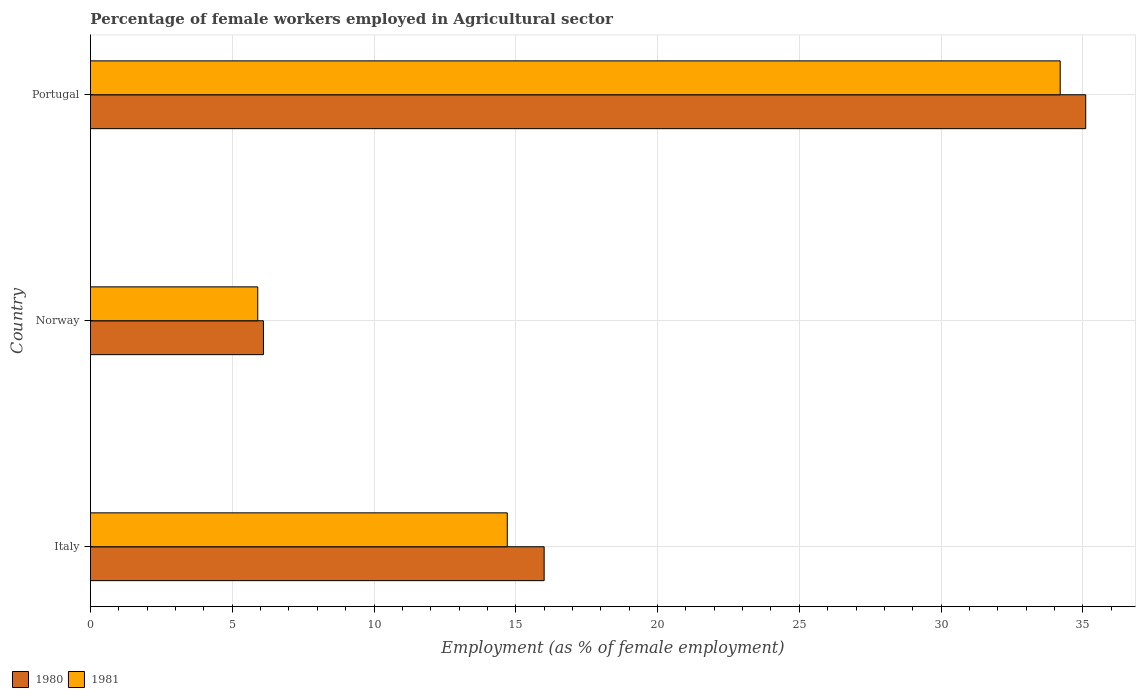How many different coloured bars are there?
Offer a very short reply. 2. How many groups of bars are there?
Offer a terse response. 3. Are the number of bars per tick equal to the number of legend labels?
Ensure brevity in your answer.  Yes. What is the label of the 3rd group of bars from the top?
Give a very brief answer. Italy. In how many cases, is the number of bars for a given country not equal to the number of legend labels?
Make the answer very short. 0. What is the percentage of females employed in Agricultural sector in 1981 in Norway?
Your answer should be very brief. 5.9. Across all countries, what is the maximum percentage of females employed in Agricultural sector in 1980?
Keep it short and to the point. 35.1. Across all countries, what is the minimum percentage of females employed in Agricultural sector in 1980?
Keep it short and to the point. 6.1. In which country was the percentage of females employed in Agricultural sector in 1981 maximum?
Offer a terse response. Portugal. In which country was the percentage of females employed in Agricultural sector in 1981 minimum?
Provide a succinct answer. Norway. What is the total percentage of females employed in Agricultural sector in 1981 in the graph?
Offer a terse response. 54.8. What is the difference between the percentage of females employed in Agricultural sector in 1981 in Italy and that in Norway?
Provide a short and direct response. 8.8. What is the difference between the percentage of females employed in Agricultural sector in 1980 in Italy and the percentage of females employed in Agricultural sector in 1981 in Norway?
Your answer should be compact. 10.1. What is the average percentage of females employed in Agricultural sector in 1981 per country?
Offer a terse response. 18.27. What is the difference between the percentage of females employed in Agricultural sector in 1980 and percentage of females employed in Agricultural sector in 1981 in Italy?
Offer a terse response. 1.3. What is the ratio of the percentage of females employed in Agricultural sector in 1981 in Italy to that in Portugal?
Your response must be concise. 0.43. Is the percentage of females employed in Agricultural sector in 1980 in Italy less than that in Portugal?
Provide a short and direct response. Yes. Is the difference between the percentage of females employed in Agricultural sector in 1980 in Italy and Portugal greater than the difference between the percentage of females employed in Agricultural sector in 1981 in Italy and Portugal?
Provide a succinct answer. Yes. What is the difference between the highest and the second highest percentage of females employed in Agricultural sector in 1981?
Offer a very short reply. 19.5. What is the difference between the highest and the lowest percentage of females employed in Agricultural sector in 1980?
Provide a succinct answer. 29. Is the sum of the percentage of females employed in Agricultural sector in 1981 in Italy and Norway greater than the maximum percentage of females employed in Agricultural sector in 1980 across all countries?
Provide a short and direct response. No. What does the 2nd bar from the top in Norway represents?
Your answer should be compact. 1980. How many bars are there?
Your answer should be very brief. 6. Are all the bars in the graph horizontal?
Provide a short and direct response. Yes. How many countries are there in the graph?
Provide a short and direct response. 3. What is the difference between two consecutive major ticks on the X-axis?
Your response must be concise. 5. Are the values on the major ticks of X-axis written in scientific E-notation?
Offer a very short reply. No. Where does the legend appear in the graph?
Provide a succinct answer. Bottom left. How are the legend labels stacked?
Offer a terse response. Horizontal. What is the title of the graph?
Offer a very short reply. Percentage of female workers employed in Agricultural sector. What is the label or title of the X-axis?
Offer a very short reply. Employment (as % of female employment). What is the Employment (as % of female employment) of 1981 in Italy?
Ensure brevity in your answer.  14.7. What is the Employment (as % of female employment) in 1980 in Norway?
Your response must be concise. 6.1. What is the Employment (as % of female employment) of 1981 in Norway?
Provide a short and direct response. 5.9. What is the Employment (as % of female employment) of 1980 in Portugal?
Offer a terse response. 35.1. What is the Employment (as % of female employment) in 1981 in Portugal?
Provide a succinct answer. 34.2. Across all countries, what is the maximum Employment (as % of female employment) in 1980?
Offer a terse response. 35.1. Across all countries, what is the maximum Employment (as % of female employment) in 1981?
Give a very brief answer. 34.2. Across all countries, what is the minimum Employment (as % of female employment) of 1980?
Your answer should be very brief. 6.1. Across all countries, what is the minimum Employment (as % of female employment) in 1981?
Make the answer very short. 5.9. What is the total Employment (as % of female employment) of 1980 in the graph?
Make the answer very short. 57.2. What is the total Employment (as % of female employment) of 1981 in the graph?
Make the answer very short. 54.8. What is the difference between the Employment (as % of female employment) of 1980 in Italy and that in Portugal?
Provide a short and direct response. -19.1. What is the difference between the Employment (as % of female employment) of 1981 in Italy and that in Portugal?
Your answer should be compact. -19.5. What is the difference between the Employment (as % of female employment) in 1980 in Norway and that in Portugal?
Provide a short and direct response. -29. What is the difference between the Employment (as % of female employment) in 1981 in Norway and that in Portugal?
Your answer should be compact. -28.3. What is the difference between the Employment (as % of female employment) in 1980 in Italy and the Employment (as % of female employment) in 1981 in Portugal?
Make the answer very short. -18.2. What is the difference between the Employment (as % of female employment) in 1980 in Norway and the Employment (as % of female employment) in 1981 in Portugal?
Provide a succinct answer. -28.1. What is the average Employment (as % of female employment) of 1980 per country?
Keep it short and to the point. 19.07. What is the average Employment (as % of female employment) of 1981 per country?
Offer a terse response. 18.27. What is the difference between the Employment (as % of female employment) in 1980 and Employment (as % of female employment) in 1981 in Norway?
Your answer should be very brief. 0.2. What is the difference between the Employment (as % of female employment) in 1980 and Employment (as % of female employment) in 1981 in Portugal?
Provide a succinct answer. 0.9. What is the ratio of the Employment (as % of female employment) in 1980 in Italy to that in Norway?
Your response must be concise. 2.62. What is the ratio of the Employment (as % of female employment) of 1981 in Italy to that in Norway?
Give a very brief answer. 2.49. What is the ratio of the Employment (as % of female employment) in 1980 in Italy to that in Portugal?
Keep it short and to the point. 0.46. What is the ratio of the Employment (as % of female employment) in 1981 in Italy to that in Portugal?
Make the answer very short. 0.43. What is the ratio of the Employment (as % of female employment) of 1980 in Norway to that in Portugal?
Your response must be concise. 0.17. What is the ratio of the Employment (as % of female employment) of 1981 in Norway to that in Portugal?
Keep it short and to the point. 0.17. What is the difference between the highest and the second highest Employment (as % of female employment) in 1981?
Your response must be concise. 19.5. What is the difference between the highest and the lowest Employment (as % of female employment) in 1980?
Make the answer very short. 29. What is the difference between the highest and the lowest Employment (as % of female employment) of 1981?
Keep it short and to the point. 28.3. 